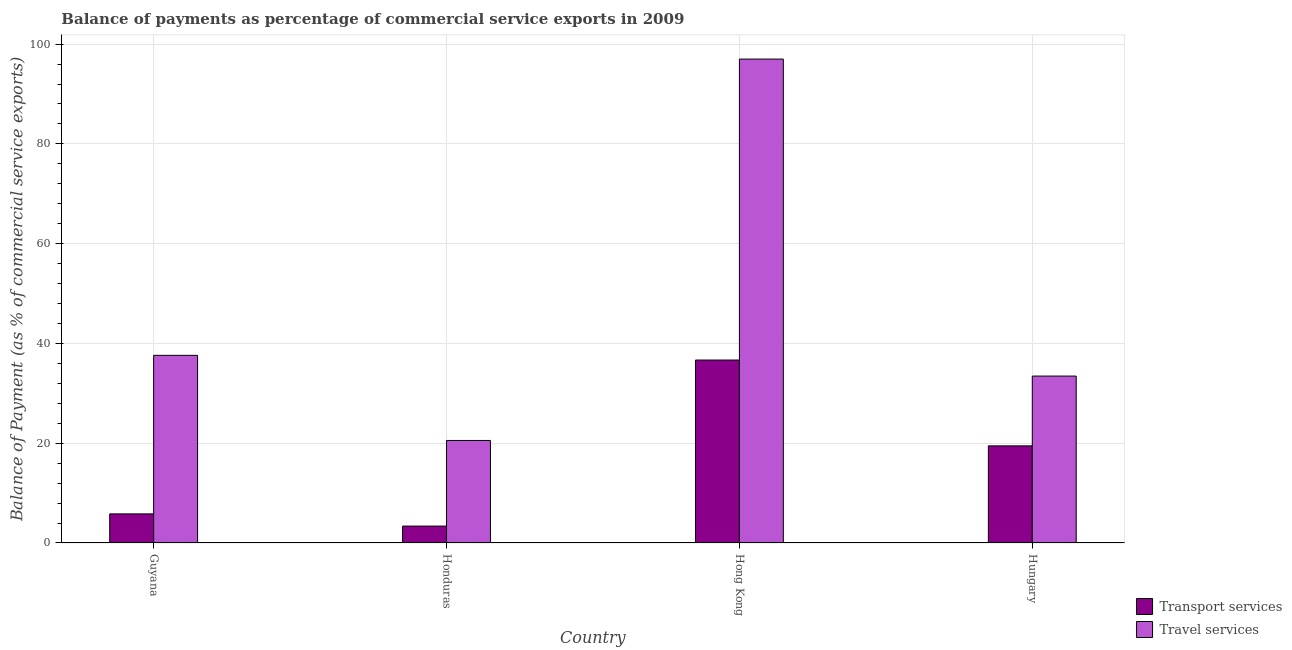How many different coloured bars are there?
Your response must be concise. 2. Are the number of bars per tick equal to the number of legend labels?
Offer a very short reply. Yes. Are the number of bars on each tick of the X-axis equal?
Your answer should be compact. Yes. How many bars are there on the 1st tick from the right?
Keep it short and to the point. 2. What is the label of the 3rd group of bars from the left?
Your answer should be very brief. Hong Kong. What is the balance of payments of travel services in Hong Kong?
Make the answer very short. 97. Across all countries, what is the maximum balance of payments of transport services?
Your answer should be very brief. 36.67. Across all countries, what is the minimum balance of payments of transport services?
Your answer should be compact. 3.39. In which country was the balance of payments of travel services maximum?
Your response must be concise. Hong Kong. In which country was the balance of payments of transport services minimum?
Give a very brief answer. Honduras. What is the total balance of payments of transport services in the graph?
Offer a very short reply. 65.37. What is the difference between the balance of payments of travel services in Guyana and that in Honduras?
Offer a terse response. 17.06. What is the difference between the balance of payments of travel services in Honduras and the balance of payments of transport services in Hungary?
Your answer should be very brief. 1.08. What is the average balance of payments of transport services per country?
Ensure brevity in your answer.  16.34. What is the difference between the balance of payments of transport services and balance of payments of travel services in Honduras?
Provide a short and direct response. -17.16. What is the ratio of the balance of payments of travel services in Guyana to that in Hungary?
Your answer should be compact. 1.12. Is the balance of payments of travel services in Guyana less than that in Hong Kong?
Make the answer very short. Yes. Is the difference between the balance of payments of transport services in Honduras and Hungary greater than the difference between the balance of payments of travel services in Honduras and Hungary?
Provide a short and direct response. No. What is the difference between the highest and the second highest balance of payments of travel services?
Your answer should be compact. 59.39. What is the difference between the highest and the lowest balance of payments of transport services?
Your answer should be compact. 33.28. In how many countries, is the balance of payments of travel services greater than the average balance of payments of travel services taken over all countries?
Offer a terse response. 1. Is the sum of the balance of payments of travel services in Guyana and Hungary greater than the maximum balance of payments of transport services across all countries?
Your response must be concise. Yes. What does the 1st bar from the left in Honduras represents?
Keep it short and to the point. Transport services. What does the 1st bar from the right in Honduras represents?
Ensure brevity in your answer.  Travel services. How many bars are there?
Your answer should be compact. 8. How many countries are there in the graph?
Your response must be concise. 4. Are the values on the major ticks of Y-axis written in scientific E-notation?
Give a very brief answer. No. Does the graph contain any zero values?
Offer a terse response. No. Where does the legend appear in the graph?
Make the answer very short. Bottom right. What is the title of the graph?
Your answer should be compact. Balance of payments as percentage of commercial service exports in 2009. Does "Foreign liabilities" appear as one of the legend labels in the graph?
Give a very brief answer. No. What is the label or title of the X-axis?
Provide a short and direct response. Country. What is the label or title of the Y-axis?
Your response must be concise. Balance of Payment (as % of commercial service exports). What is the Balance of Payment (as % of commercial service exports) of Transport services in Guyana?
Your answer should be very brief. 5.84. What is the Balance of Payment (as % of commercial service exports) of Travel services in Guyana?
Provide a succinct answer. 37.61. What is the Balance of Payment (as % of commercial service exports) of Transport services in Honduras?
Your answer should be compact. 3.39. What is the Balance of Payment (as % of commercial service exports) of Travel services in Honduras?
Your response must be concise. 20.55. What is the Balance of Payment (as % of commercial service exports) of Transport services in Hong Kong?
Your response must be concise. 36.67. What is the Balance of Payment (as % of commercial service exports) of Travel services in Hong Kong?
Offer a very short reply. 97. What is the Balance of Payment (as % of commercial service exports) of Transport services in Hungary?
Make the answer very short. 19.47. What is the Balance of Payment (as % of commercial service exports) in Travel services in Hungary?
Your response must be concise. 33.46. Across all countries, what is the maximum Balance of Payment (as % of commercial service exports) in Transport services?
Your answer should be very brief. 36.67. Across all countries, what is the maximum Balance of Payment (as % of commercial service exports) of Travel services?
Your response must be concise. 97. Across all countries, what is the minimum Balance of Payment (as % of commercial service exports) in Transport services?
Keep it short and to the point. 3.39. Across all countries, what is the minimum Balance of Payment (as % of commercial service exports) in Travel services?
Keep it short and to the point. 20.55. What is the total Balance of Payment (as % of commercial service exports) of Transport services in the graph?
Make the answer very short. 65.37. What is the total Balance of Payment (as % of commercial service exports) in Travel services in the graph?
Offer a very short reply. 188.62. What is the difference between the Balance of Payment (as % of commercial service exports) of Transport services in Guyana and that in Honduras?
Offer a very short reply. 2.45. What is the difference between the Balance of Payment (as % of commercial service exports) in Travel services in Guyana and that in Honduras?
Give a very brief answer. 17.06. What is the difference between the Balance of Payment (as % of commercial service exports) of Transport services in Guyana and that in Hong Kong?
Your response must be concise. -30.84. What is the difference between the Balance of Payment (as % of commercial service exports) of Travel services in Guyana and that in Hong Kong?
Give a very brief answer. -59.39. What is the difference between the Balance of Payment (as % of commercial service exports) in Transport services in Guyana and that in Hungary?
Give a very brief answer. -13.63. What is the difference between the Balance of Payment (as % of commercial service exports) of Travel services in Guyana and that in Hungary?
Offer a terse response. 4.16. What is the difference between the Balance of Payment (as % of commercial service exports) of Transport services in Honduras and that in Hong Kong?
Provide a succinct answer. -33.28. What is the difference between the Balance of Payment (as % of commercial service exports) of Travel services in Honduras and that in Hong Kong?
Make the answer very short. -76.45. What is the difference between the Balance of Payment (as % of commercial service exports) of Transport services in Honduras and that in Hungary?
Give a very brief answer. -16.08. What is the difference between the Balance of Payment (as % of commercial service exports) of Travel services in Honduras and that in Hungary?
Provide a short and direct response. -12.91. What is the difference between the Balance of Payment (as % of commercial service exports) in Transport services in Hong Kong and that in Hungary?
Your answer should be very brief. 17.2. What is the difference between the Balance of Payment (as % of commercial service exports) of Travel services in Hong Kong and that in Hungary?
Keep it short and to the point. 63.54. What is the difference between the Balance of Payment (as % of commercial service exports) of Transport services in Guyana and the Balance of Payment (as % of commercial service exports) of Travel services in Honduras?
Provide a short and direct response. -14.72. What is the difference between the Balance of Payment (as % of commercial service exports) in Transport services in Guyana and the Balance of Payment (as % of commercial service exports) in Travel services in Hong Kong?
Your answer should be very brief. -91.16. What is the difference between the Balance of Payment (as % of commercial service exports) of Transport services in Guyana and the Balance of Payment (as % of commercial service exports) of Travel services in Hungary?
Provide a succinct answer. -27.62. What is the difference between the Balance of Payment (as % of commercial service exports) in Transport services in Honduras and the Balance of Payment (as % of commercial service exports) in Travel services in Hong Kong?
Your response must be concise. -93.61. What is the difference between the Balance of Payment (as % of commercial service exports) in Transport services in Honduras and the Balance of Payment (as % of commercial service exports) in Travel services in Hungary?
Your answer should be compact. -30.07. What is the difference between the Balance of Payment (as % of commercial service exports) in Transport services in Hong Kong and the Balance of Payment (as % of commercial service exports) in Travel services in Hungary?
Keep it short and to the point. 3.22. What is the average Balance of Payment (as % of commercial service exports) in Transport services per country?
Offer a terse response. 16.34. What is the average Balance of Payment (as % of commercial service exports) of Travel services per country?
Your answer should be compact. 47.16. What is the difference between the Balance of Payment (as % of commercial service exports) in Transport services and Balance of Payment (as % of commercial service exports) in Travel services in Guyana?
Provide a succinct answer. -31.78. What is the difference between the Balance of Payment (as % of commercial service exports) of Transport services and Balance of Payment (as % of commercial service exports) of Travel services in Honduras?
Give a very brief answer. -17.16. What is the difference between the Balance of Payment (as % of commercial service exports) in Transport services and Balance of Payment (as % of commercial service exports) in Travel services in Hong Kong?
Your answer should be very brief. -60.33. What is the difference between the Balance of Payment (as % of commercial service exports) of Transport services and Balance of Payment (as % of commercial service exports) of Travel services in Hungary?
Offer a very short reply. -13.99. What is the ratio of the Balance of Payment (as % of commercial service exports) of Transport services in Guyana to that in Honduras?
Provide a succinct answer. 1.72. What is the ratio of the Balance of Payment (as % of commercial service exports) in Travel services in Guyana to that in Honduras?
Your answer should be compact. 1.83. What is the ratio of the Balance of Payment (as % of commercial service exports) in Transport services in Guyana to that in Hong Kong?
Keep it short and to the point. 0.16. What is the ratio of the Balance of Payment (as % of commercial service exports) of Travel services in Guyana to that in Hong Kong?
Provide a short and direct response. 0.39. What is the ratio of the Balance of Payment (as % of commercial service exports) in Transport services in Guyana to that in Hungary?
Make the answer very short. 0.3. What is the ratio of the Balance of Payment (as % of commercial service exports) of Travel services in Guyana to that in Hungary?
Provide a succinct answer. 1.12. What is the ratio of the Balance of Payment (as % of commercial service exports) of Transport services in Honduras to that in Hong Kong?
Your answer should be compact. 0.09. What is the ratio of the Balance of Payment (as % of commercial service exports) in Travel services in Honduras to that in Hong Kong?
Give a very brief answer. 0.21. What is the ratio of the Balance of Payment (as % of commercial service exports) in Transport services in Honduras to that in Hungary?
Provide a short and direct response. 0.17. What is the ratio of the Balance of Payment (as % of commercial service exports) in Travel services in Honduras to that in Hungary?
Provide a short and direct response. 0.61. What is the ratio of the Balance of Payment (as % of commercial service exports) of Transport services in Hong Kong to that in Hungary?
Make the answer very short. 1.88. What is the ratio of the Balance of Payment (as % of commercial service exports) in Travel services in Hong Kong to that in Hungary?
Your answer should be compact. 2.9. What is the difference between the highest and the second highest Balance of Payment (as % of commercial service exports) in Transport services?
Your response must be concise. 17.2. What is the difference between the highest and the second highest Balance of Payment (as % of commercial service exports) of Travel services?
Offer a very short reply. 59.39. What is the difference between the highest and the lowest Balance of Payment (as % of commercial service exports) of Transport services?
Your answer should be compact. 33.28. What is the difference between the highest and the lowest Balance of Payment (as % of commercial service exports) of Travel services?
Your answer should be compact. 76.45. 